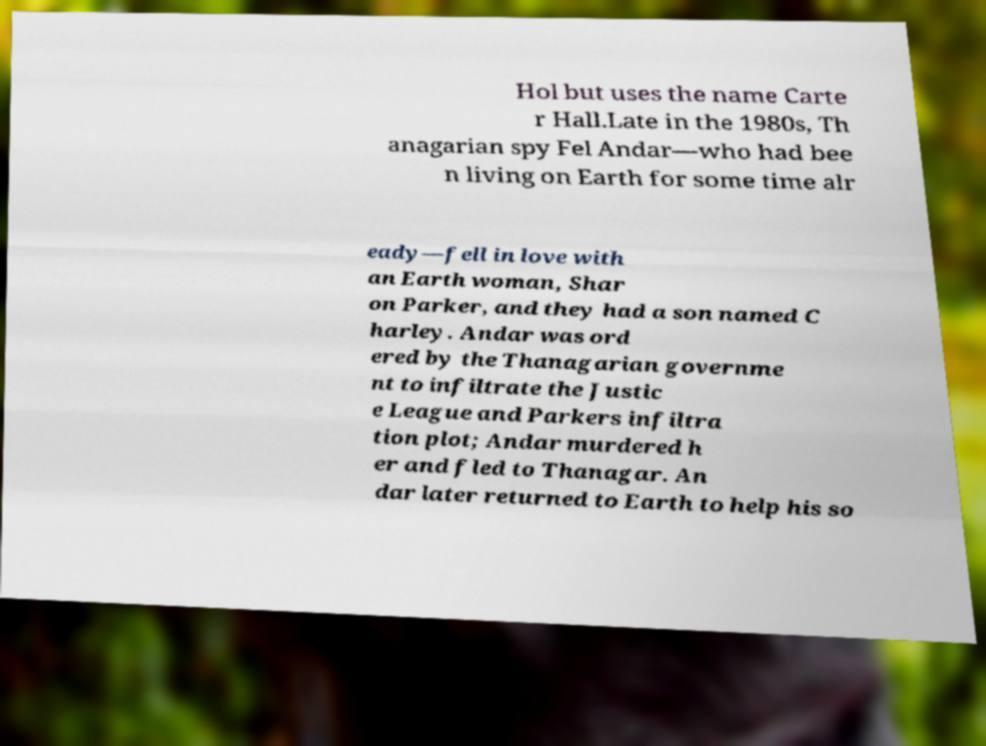I need the written content from this picture converted into text. Can you do that? Hol but uses the name Carte r Hall.Late in the 1980s, Th anagarian spy Fel Andar—who had bee n living on Earth for some time alr eady—fell in love with an Earth woman, Shar on Parker, and they had a son named C harley. Andar was ord ered by the Thanagarian governme nt to infiltrate the Justic e League and Parkers infiltra tion plot; Andar murdered h er and fled to Thanagar. An dar later returned to Earth to help his so 